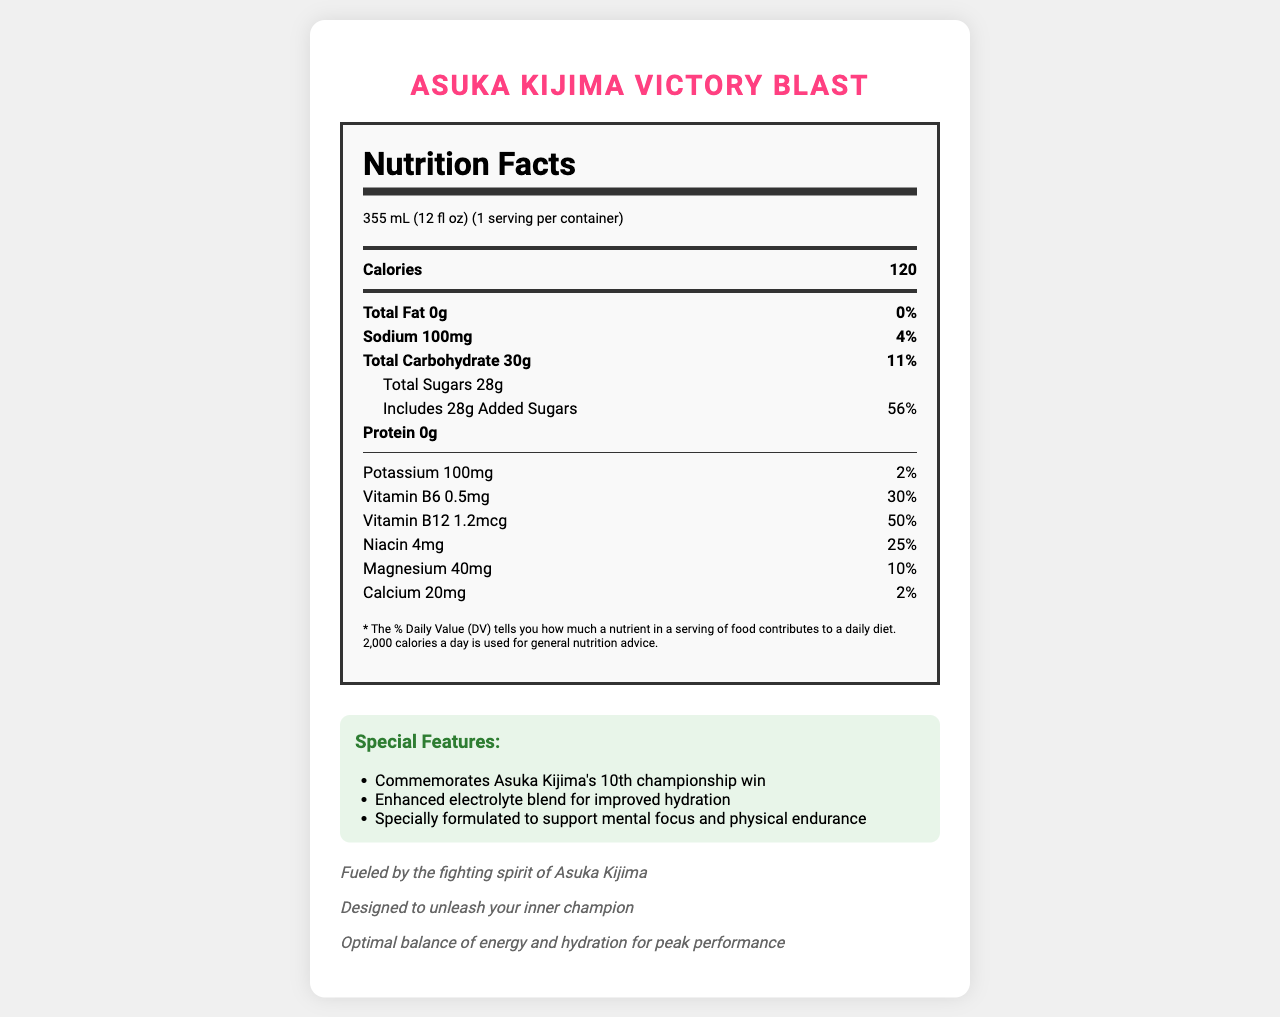what is the sodium content per serving? The nutrition facts label shows that the sodium content per serving is 100mg.
Answer: 100mg what is the serving size of the Asuka Kijima Victory Blast? The document specifies that the serving size is 355 mL, which is equivalent to 12 fluid ounces.
Answer: 355 mL (12 fl oz) how many total carbohydrates are there per serving? According to the label, there are 30 grams of total carbohydrates per serving.
Answer: 30g what is the main feature of the Asuka Kijima Victory Blast related to hydration? The special features section mentions "Enhanced electrolyte blend for improved hydration."
Answer: Enhanced electrolyte blend how much caffeine is in one can of the Asuka Kijima Victory Blast? The caffeine content is stated to be 150mg per can.
Answer: 150mg how much Vitamin B12 does one serving contain? The nutrition facts indicate that one serving contains 1.2 micrograms of Vitamin B12.
Answer: 1.2mcg what percentage of the daily value of Vitamin B6 is in one serving? A. 20% B. 25% C. 30% D. 50% The document states that there is 0.5mg of Vitamin B6 which is 30% of the daily value (DV).
Answer: C. 30% which ingredient is NOT listed in the "other ingredients" section? A. Citric Acid B. Panax Ginseng Root Extract C. Turmeric D. Maltodextrin Turmeric is not listed in the "other ingredients" section, while the others are.
Answer: C. Turmeric does the drink contain any protein? The label clearly shows that the protein content is 0g.
Answer: No can you determine the price of the Asuka Kijima Victory Blast from the document? The document provides nutritional information and special features but does not include any pricing information.
Answer: Cannot be determined summarize the main purpose and features of the Asuka Kijima Victory Blast energy drink. The drink aims to celebrate Asuka Kijima's achievements while providing an optimal balance of energy and hydration to enhance performance. The detailed nutrition facts highlight its electrolyte content and supporting ingredients.
Answer: The Asuka Kijima Victory Blast is a special edition energy drink designed to commemorate Asuka Kijima's career milestones. It contains 120 calories per serving with an enhanced electrolyte blend for improved hydration, 150mg of caffeine for energy, and a variety of vitamins and minerals, including Vitamin B6, B12, Niacin, Magnesium, and Calcium. It is marketed to support mental focus and physical endurance and is described as being fueled by Asuka Kijima's fighting spirit. 